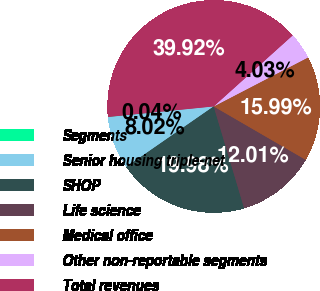<chart> <loc_0><loc_0><loc_500><loc_500><pie_chart><fcel>Segments<fcel>Senior housing triple-net<fcel>SHOP<fcel>Life science<fcel>Medical office<fcel>Other non-reportable segments<fcel>Total revenues<nl><fcel>0.04%<fcel>8.02%<fcel>19.98%<fcel>12.01%<fcel>15.99%<fcel>4.03%<fcel>39.92%<nl></chart> 